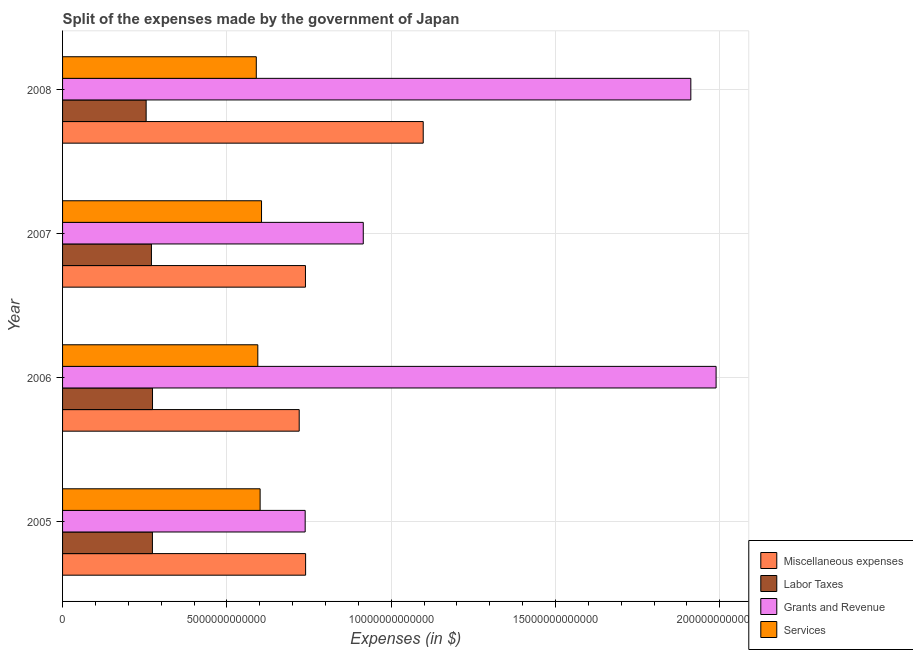How many different coloured bars are there?
Offer a terse response. 4. Are the number of bars per tick equal to the number of legend labels?
Provide a succinct answer. Yes. How many bars are there on the 2nd tick from the bottom?
Keep it short and to the point. 4. What is the amount spent on services in 2007?
Provide a short and direct response. 6.06e+12. Across all years, what is the maximum amount spent on miscellaneous expenses?
Offer a terse response. 1.10e+13. Across all years, what is the minimum amount spent on services?
Your response must be concise. 5.90e+12. What is the total amount spent on services in the graph?
Your answer should be compact. 2.39e+13. What is the difference between the amount spent on miscellaneous expenses in 2005 and that in 2007?
Give a very brief answer. 4.50e+09. What is the difference between the amount spent on labor taxes in 2006 and the amount spent on grants and revenue in 2005?
Offer a very short reply. -4.65e+12. What is the average amount spent on labor taxes per year?
Provide a short and direct response. 2.68e+12. In the year 2008, what is the difference between the amount spent on grants and revenue and amount spent on services?
Offer a terse response. 1.32e+13. Is the amount spent on services in 2005 less than that in 2006?
Your response must be concise. No. What is the difference between the highest and the second highest amount spent on grants and revenue?
Keep it short and to the point. 7.69e+11. What is the difference between the highest and the lowest amount spent on services?
Keep it short and to the point. 1.59e+11. In how many years, is the amount spent on services greater than the average amount spent on services taken over all years?
Your response must be concise. 2. Is the sum of the amount spent on miscellaneous expenses in 2005 and 2008 greater than the maximum amount spent on labor taxes across all years?
Ensure brevity in your answer.  Yes. Is it the case that in every year, the sum of the amount spent on grants and revenue and amount spent on services is greater than the sum of amount spent on labor taxes and amount spent on miscellaneous expenses?
Your response must be concise. No. What does the 4th bar from the top in 2007 represents?
Give a very brief answer. Miscellaneous expenses. What does the 1st bar from the bottom in 2006 represents?
Make the answer very short. Miscellaneous expenses. What is the difference between two consecutive major ticks on the X-axis?
Provide a short and direct response. 5.00e+12. Does the graph contain grids?
Keep it short and to the point. Yes. Where does the legend appear in the graph?
Offer a very short reply. Bottom right. How many legend labels are there?
Make the answer very short. 4. What is the title of the graph?
Keep it short and to the point. Split of the expenses made by the government of Japan. Does "Financial sector" appear as one of the legend labels in the graph?
Offer a very short reply. No. What is the label or title of the X-axis?
Keep it short and to the point. Expenses (in $). What is the label or title of the Y-axis?
Make the answer very short. Year. What is the Expenses (in $) of Miscellaneous expenses in 2005?
Offer a very short reply. 7.40e+12. What is the Expenses (in $) in Labor Taxes in 2005?
Your answer should be compact. 2.73e+12. What is the Expenses (in $) of Grants and Revenue in 2005?
Your response must be concise. 7.38e+12. What is the Expenses (in $) in Services in 2005?
Keep it short and to the point. 6.01e+12. What is the Expenses (in $) in Miscellaneous expenses in 2006?
Keep it short and to the point. 7.20e+12. What is the Expenses (in $) in Labor Taxes in 2006?
Give a very brief answer. 2.74e+12. What is the Expenses (in $) of Grants and Revenue in 2006?
Give a very brief answer. 1.99e+13. What is the Expenses (in $) of Services in 2006?
Ensure brevity in your answer.  5.94e+12. What is the Expenses (in $) in Miscellaneous expenses in 2007?
Give a very brief answer. 7.39e+12. What is the Expenses (in $) in Labor Taxes in 2007?
Make the answer very short. 2.70e+12. What is the Expenses (in $) of Grants and Revenue in 2007?
Provide a succinct answer. 9.15e+12. What is the Expenses (in $) in Services in 2007?
Your response must be concise. 6.06e+12. What is the Expenses (in $) of Miscellaneous expenses in 2008?
Keep it short and to the point. 1.10e+13. What is the Expenses (in $) of Labor Taxes in 2008?
Provide a succinct answer. 2.54e+12. What is the Expenses (in $) of Grants and Revenue in 2008?
Your response must be concise. 1.91e+13. What is the Expenses (in $) in Services in 2008?
Give a very brief answer. 5.90e+12. Across all years, what is the maximum Expenses (in $) of Miscellaneous expenses?
Make the answer very short. 1.10e+13. Across all years, what is the maximum Expenses (in $) of Labor Taxes?
Keep it short and to the point. 2.74e+12. Across all years, what is the maximum Expenses (in $) of Grants and Revenue?
Ensure brevity in your answer.  1.99e+13. Across all years, what is the maximum Expenses (in $) of Services?
Make the answer very short. 6.06e+12. Across all years, what is the minimum Expenses (in $) in Miscellaneous expenses?
Offer a very short reply. 7.20e+12. Across all years, what is the minimum Expenses (in $) of Labor Taxes?
Keep it short and to the point. 2.54e+12. Across all years, what is the minimum Expenses (in $) in Grants and Revenue?
Ensure brevity in your answer.  7.38e+12. Across all years, what is the minimum Expenses (in $) of Services?
Ensure brevity in your answer.  5.90e+12. What is the total Expenses (in $) in Miscellaneous expenses in the graph?
Keep it short and to the point. 3.30e+13. What is the total Expenses (in $) in Labor Taxes in the graph?
Provide a short and direct response. 1.07e+13. What is the total Expenses (in $) of Grants and Revenue in the graph?
Keep it short and to the point. 5.55e+13. What is the total Expenses (in $) of Services in the graph?
Ensure brevity in your answer.  2.39e+13. What is the difference between the Expenses (in $) of Miscellaneous expenses in 2005 and that in 2006?
Your response must be concise. 1.95e+11. What is the difference between the Expenses (in $) in Labor Taxes in 2005 and that in 2006?
Your response must be concise. -2.70e+09. What is the difference between the Expenses (in $) in Grants and Revenue in 2005 and that in 2006?
Offer a very short reply. -1.25e+13. What is the difference between the Expenses (in $) of Services in 2005 and that in 2006?
Make the answer very short. 7.08e+1. What is the difference between the Expenses (in $) in Miscellaneous expenses in 2005 and that in 2007?
Your answer should be compact. 4.50e+09. What is the difference between the Expenses (in $) of Labor Taxes in 2005 and that in 2007?
Provide a succinct answer. 3.01e+1. What is the difference between the Expenses (in $) in Grants and Revenue in 2005 and that in 2007?
Make the answer very short. -1.77e+12. What is the difference between the Expenses (in $) of Services in 2005 and that in 2007?
Keep it short and to the point. -4.26e+1. What is the difference between the Expenses (in $) in Miscellaneous expenses in 2005 and that in 2008?
Offer a very short reply. -3.58e+12. What is the difference between the Expenses (in $) of Labor Taxes in 2005 and that in 2008?
Your answer should be compact. 1.91e+11. What is the difference between the Expenses (in $) of Grants and Revenue in 2005 and that in 2008?
Your answer should be compact. -1.17e+13. What is the difference between the Expenses (in $) of Services in 2005 and that in 2008?
Provide a short and direct response. 1.17e+11. What is the difference between the Expenses (in $) of Miscellaneous expenses in 2006 and that in 2007?
Provide a short and direct response. -1.90e+11. What is the difference between the Expenses (in $) in Labor Taxes in 2006 and that in 2007?
Make the answer very short. 3.28e+1. What is the difference between the Expenses (in $) of Grants and Revenue in 2006 and that in 2007?
Your answer should be very brief. 1.07e+13. What is the difference between the Expenses (in $) of Services in 2006 and that in 2007?
Make the answer very short. -1.13e+11. What is the difference between the Expenses (in $) of Miscellaneous expenses in 2006 and that in 2008?
Offer a very short reply. -3.77e+12. What is the difference between the Expenses (in $) of Labor Taxes in 2006 and that in 2008?
Make the answer very short. 1.94e+11. What is the difference between the Expenses (in $) in Grants and Revenue in 2006 and that in 2008?
Offer a terse response. 7.69e+11. What is the difference between the Expenses (in $) in Services in 2006 and that in 2008?
Keep it short and to the point. 4.59e+1. What is the difference between the Expenses (in $) of Miscellaneous expenses in 2007 and that in 2008?
Offer a very short reply. -3.58e+12. What is the difference between the Expenses (in $) of Labor Taxes in 2007 and that in 2008?
Give a very brief answer. 1.61e+11. What is the difference between the Expenses (in $) in Grants and Revenue in 2007 and that in 2008?
Provide a succinct answer. -9.97e+12. What is the difference between the Expenses (in $) of Services in 2007 and that in 2008?
Make the answer very short. 1.59e+11. What is the difference between the Expenses (in $) in Miscellaneous expenses in 2005 and the Expenses (in $) in Labor Taxes in 2006?
Ensure brevity in your answer.  4.66e+12. What is the difference between the Expenses (in $) of Miscellaneous expenses in 2005 and the Expenses (in $) of Grants and Revenue in 2006?
Make the answer very short. -1.25e+13. What is the difference between the Expenses (in $) of Miscellaneous expenses in 2005 and the Expenses (in $) of Services in 2006?
Your response must be concise. 1.45e+12. What is the difference between the Expenses (in $) in Labor Taxes in 2005 and the Expenses (in $) in Grants and Revenue in 2006?
Your answer should be very brief. -1.72e+13. What is the difference between the Expenses (in $) in Labor Taxes in 2005 and the Expenses (in $) in Services in 2006?
Your answer should be compact. -3.21e+12. What is the difference between the Expenses (in $) of Grants and Revenue in 2005 and the Expenses (in $) of Services in 2006?
Provide a short and direct response. 1.44e+12. What is the difference between the Expenses (in $) of Miscellaneous expenses in 2005 and the Expenses (in $) of Labor Taxes in 2007?
Your answer should be compact. 4.69e+12. What is the difference between the Expenses (in $) in Miscellaneous expenses in 2005 and the Expenses (in $) in Grants and Revenue in 2007?
Give a very brief answer. -1.75e+12. What is the difference between the Expenses (in $) in Miscellaneous expenses in 2005 and the Expenses (in $) in Services in 2007?
Your answer should be compact. 1.34e+12. What is the difference between the Expenses (in $) of Labor Taxes in 2005 and the Expenses (in $) of Grants and Revenue in 2007?
Give a very brief answer. -6.42e+12. What is the difference between the Expenses (in $) of Labor Taxes in 2005 and the Expenses (in $) of Services in 2007?
Keep it short and to the point. -3.32e+12. What is the difference between the Expenses (in $) of Grants and Revenue in 2005 and the Expenses (in $) of Services in 2007?
Offer a very short reply. 1.33e+12. What is the difference between the Expenses (in $) of Miscellaneous expenses in 2005 and the Expenses (in $) of Labor Taxes in 2008?
Your answer should be compact. 4.85e+12. What is the difference between the Expenses (in $) of Miscellaneous expenses in 2005 and the Expenses (in $) of Grants and Revenue in 2008?
Your response must be concise. -1.17e+13. What is the difference between the Expenses (in $) in Miscellaneous expenses in 2005 and the Expenses (in $) in Services in 2008?
Offer a very short reply. 1.50e+12. What is the difference between the Expenses (in $) in Labor Taxes in 2005 and the Expenses (in $) in Grants and Revenue in 2008?
Offer a very short reply. -1.64e+13. What is the difference between the Expenses (in $) of Labor Taxes in 2005 and the Expenses (in $) of Services in 2008?
Make the answer very short. -3.16e+12. What is the difference between the Expenses (in $) of Grants and Revenue in 2005 and the Expenses (in $) of Services in 2008?
Offer a very short reply. 1.49e+12. What is the difference between the Expenses (in $) in Miscellaneous expenses in 2006 and the Expenses (in $) in Labor Taxes in 2007?
Ensure brevity in your answer.  4.50e+12. What is the difference between the Expenses (in $) in Miscellaneous expenses in 2006 and the Expenses (in $) in Grants and Revenue in 2007?
Offer a very short reply. -1.95e+12. What is the difference between the Expenses (in $) of Miscellaneous expenses in 2006 and the Expenses (in $) of Services in 2007?
Provide a short and direct response. 1.15e+12. What is the difference between the Expenses (in $) of Labor Taxes in 2006 and the Expenses (in $) of Grants and Revenue in 2007?
Your response must be concise. -6.41e+12. What is the difference between the Expenses (in $) in Labor Taxes in 2006 and the Expenses (in $) in Services in 2007?
Ensure brevity in your answer.  -3.32e+12. What is the difference between the Expenses (in $) in Grants and Revenue in 2006 and the Expenses (in $) in Services in 2007?
Keep it short and to the point. 1.38e+13. What is the difference between the Expenses (in $) of Miscellaneous expenses in 2006 and the Expenses (in $) of Labor Taxes in 2008?
Make the answer very short. 4.66e+12. What is the difference between the Expenses (in $) in Miscellaneous expenses in 2006 and the Expenses (in $) in Grants and Revenue in 2008?
Provide a succinct answer. -1.19e+13. What is the difference between the Expenses (in $) of Miscellaneous expenses in 2006 and the Expenses (in $) of Services in 2008?
Offer a terse response. 1.31e+12. What is the difference between the Expenses (in $) of Labor Taxes in 2006 and the Expenses (in $) of Grants and Revenue in 2008?
Your answer should be very brief. -1.64e+13. What is the difference between the Expenses (in $) of Labor Taxes in 2006 and the Expenses (in $) of Services in 2008?
Offer a very short reply. -3.16e+12. What is the difference between the Expenses (in $) in Grants and Revenue in 2006 and the Expenses (in $) in Services in 2008?
Your answer should be compact. 1.40e+13. What is the difference between the Expenses (in $) of Miscellaneous expenses in 2007 and the Expenses (in $) of Labor Taxes in 2008?
Provide a short and direct response. 4.85e+12. What is the difference between the Expenses (in $) of Miscellaneous expenses in 2007 and the Expenses (in $) of Grants and Revenue in 2008?
Provide a succinct answer. -1.17e+13. What is the difference between the Expenses (in $) in Miscellaneous expenses in 2007 and the Expenses (in $) in Services in 2008?
Keep it short and to the point. 1.50e+12. What is the difference between the Expenses (in $) in Labor Taxes in 2007 and the Expenses (in $) in Grants and Revenue in 2008?
Make the answer very short. -1.64e+13. What is the difference between the Expenses (in $) in Labor Taxes in 2007 and the Expenses (in $) in Services in 2008?
Your answer should be compact. -3.19e+12. What is the difference between the Expenses (in $) of Grants and Revenue in 2007 and the Expenses (in $) of Services in 2008?
Provide a succinct answer. 3.26e+12. What is the average Expenses (in $) in Miscellaneous expenses per year?
Your answer should be very brief. 8.24e+12. What is the average Expenses (in $) in Labor Taxes per year?
Ensure brevity in your answer.  2.68e+12. What is the average Expenses (in $) in Grants and Revenue per year?
Your answer should be compact. 1.39e+13. What is the average Expenses (in $) in Services per year?
Ensure brevity in your answer.  5.98e+12. In the year 2005, what is the difference between the Expenses (in $) of Miscellaneous expenses and Expenses (in $) of Labor Taxes?
Give a very brief answer. 4.66e+12. In the year 2005, what is the difference between the Expenses (in $) in Miscellaneous expenses and Expenses (in $) in Grants and Revenue?
Offer a terse response. 1.34e+1. In the year 2005, what is the difference between the Expenses (in $) of Miscellaneous expenses and Expenses (in $) of Services?
Make the answer very short. 1.38e+12. In the year 2005, what is the difference between the Expenses (in $) of Labor Taxes and Expenses (in $) of Grants and Revenue?
Provide a short and direct response. -4.65e+12. In the year 2005, what is the difference between the Expenses (in $) of Labor Taxes and Expenses (in $) of Services?
Give a very brief answer. -3.28e+12. In the year 2005, what is the difference between the Expenses (in $) in Grants and Revenue and Expenses (in $) in Services?
Your answer should be compact. 1.37e+12. In the year 2006, what is the difference between the Expenses (in $) in Miscellaneous expenses and Expenses (in $) in Labor Taxes?
Ensure brevity in your answer.  4.46e+12. In the year 2006, what is the difference between the Expenses (in $) in Miscellaneous expenses and Expenses (in $) in Grants and Revenue?
Make the answer very short. -1.27e+13. In the year 2006, what is the difference between the Expenses (in $) of Miscellaneous expenses and Expenses (in $) of Services?
Provide a short and direct response. 1.26e+12. In the year 2006, what is the difference between the Expenses (in $) in Labor Taxes and Expenses (in $) in Grants and Revenue?
Give a very brief answer. -1.72e+13. In the year 2006, what is the difference between the Expenses (in $) of Labor Taxes and Expenses (in $) of Services?
Offer a very short reply. -3.20e+12. In the year 2006, what is the difference between the Expenses (in $) in Grants and Revenue and Expenses (in $) in Services?
Make the answer very short. 1.39e+13. In the year 2007, what is the difference between the Expenses (in $) in Miscellaneous expenses and Expenses (in $) in Labor Taxes?
Ensure brevity in your answer.  4.69e+12. In the year 2007, what is the difference between the Expenses (in $) of Miscellaneous expenses and Expenses (in $) of Grants and Revenue?
Keep it short and to the point. -1.76e+12. In the year 2007, what is the difference between the Expenses (in $) of Miscellaneous expenses and Expenses (in $) of Services?
Make the answer very short. 1.34e+12. In the year 2007, what is the difference between the Expenses (in $) in Labor Taxes and Expenses (in $) in Grants and Revenue?
Your answer should be compact. -6.45e+12. In the year 2007, what is the difference between the Expenses (in $) in Labor Taxes and Expenses (in $) in Services?
Your answer should be very brief. -3.35e+12. In the year 2007, what is the difference between the Expenses (in $) of Grants and Revenue and Expenses (in $) of Services?
Make the answer very short. 3.10e+12. In the year 2008, what is the difference between the Expenses (in $) in Miscellaneous expenses and Expenses (in $) in Labor Taxes?
Offer a very short reply. 8.43e+12. In the year 2008, what is the difference between the Expenses (in $) of Miscellaneous expenses and Expenses (in $) of Grants and Revenue?
Your response must be concise. -8.14e+12. In the year 2008, what is the difference between the Expenses (in $) of Miscellaneous expenses and Expenses (in $) of Services?
Your response must be concise. 5.08e+12. In the year 2008, what is the difference between the Expenses (in $) of Labor Taxes and Expenses (in $) of Grants and Revenue?
Your answer should be very brief. -1.66e+13. In the year 2008, what is the difference between the Expenses (in $) of Labor Taxes and Expenses (in $) of Services?
Provide a short and direct response. -3.35e+12. In the year 2008, what is the difference between the Expenses (in $) in Grants and Revenue and Expenses (in $) in Services?
Offer a terse response. 1.32e+13. What is the ratio of the Expenses (in $) in Grants and Revenue in 2005 to that in 2006?
Provide a succinct answer. 0.37. What is the ratio of the Expenses (in $) in Services in 2005 to that in 2006?
Offer a terse response. 1.01. What is the ratio of the Expenses (in $) in Miscellaneous expenses in 2005 to that in 2007?
Provide a succinct answer. 1. What is the ratio of the Expenses (in $) in Labor Taxes in 2005 to that in 2007?
Your answer should be very brief. 1.01. What is the ratio of the Expenses (in $) of Grants and Revenue in 2005 to that in 2007?
Your response must be concise. 0.81. What is the ratio of the Expenses (in $) in Services in 2005 to that in 2007?
Give a very brief answer. 0.99. What is the ratio of the Expenses (in $) in Miscellaneous expenses in 2005 to that in 2008?
Offer a terse response. 0.67. What is the ratio of the Expenses (in $) in Labor Taxes in 2005 to that in 2008?
Keep it short and to the point. 1.08. What is the ratio of the Expenses (in $) of Grants and Revenue in 2005 to that in 2008?
Your response must be concise. 0.39. What is the ratio of the Expenses (in $) in Services in 2005 to that in 2008?
Offer a very short reply. 1.02. What is the ratio of the Expenses (in $) of Miscellaneous expenses in 2006 to that in 2007?
Make the answer very short. 0.97. What is the ratio of the Expenses (in $) in Labor Taxes in 2006 to that in 2007?
Keep it short and to the point. 1.01. What is the ratio of the Expenses (in $) of Grants and Revenue in 2006 to that in 2007?
Give a very brief answer. 2.17. What is the ratio of the Expenses (in $) in Services in 2006 to that in 2007?
Provide a succinct answer. 0.98. What is the ratio of the Expenses (in $) in Miscellaneous expenses in 2006 to that in 2008?
Give a very brief answer. 0.66. What is the ratio of the Expenses (in $) of Labor Taxes in 2006 to that in 2008?
Offer a very short reply. 1.08. What is the ratio of the Expenses (in $) in Grants and Revenue in 2006 to that in 2008?
Provide a short and direct response. 1.04. What is the ratio of the Expenses (in $) in Services in 2006 to that in 2008?
Make the answer very short. 1.01. What is the ratio of the Expenses (in $) in Miscellaneous expenses in 2007 to that in 2008?
Your answer should be very brief. 0.67. What is the ratio of the Expenses (in $) of Labor Taxes in 2007 to that in 2008?
Offer a terse response. 1.06. What is the ratio of the Expenses (in $) of Grants and Revenue in 2007 to that in 2008?
Your answer should be compact. 0.48. What is the ratio of the Expenses (in $) of Services in 2007 to that in 2008?
Provide a short and direct response. 1.03. What is the difference between the highest and the second highest Expenses (in $) in Miscellaneous expenses?
Your response must be concise. 3.58e+12. What is the difference between the highest and the second highest Expenses (in $) of Labor Taxes?
Your answer should be very brief. 2.70e+09. What is the difference between the highest and the second highest Expenses (in $) of Grants and Revenue?
Provide a succinct answer. 7.69e+11. What is the difference between the highest and the second highest Expenses (in $) of Services?
Offer a terse response. 4.26e+1. What is the difference between the highest and the lowest Expenses (in $) in Miscellaneous expenses?
Give a very brief answer. 3.77e+12. What is the difference between the highest and the lowest Expenses (in $) in Labor Taxes?
Ensure brevity in your answer.  1.94e+11. What is the difference between the highest and the lowest Expenses (in $) in Grants and Revenue?
Offer a terse response. 1.25e+13. What is the difference between the highest and the lowest Expenses (in $) in Services?
Your answer should be compact. 1.59e+11. 